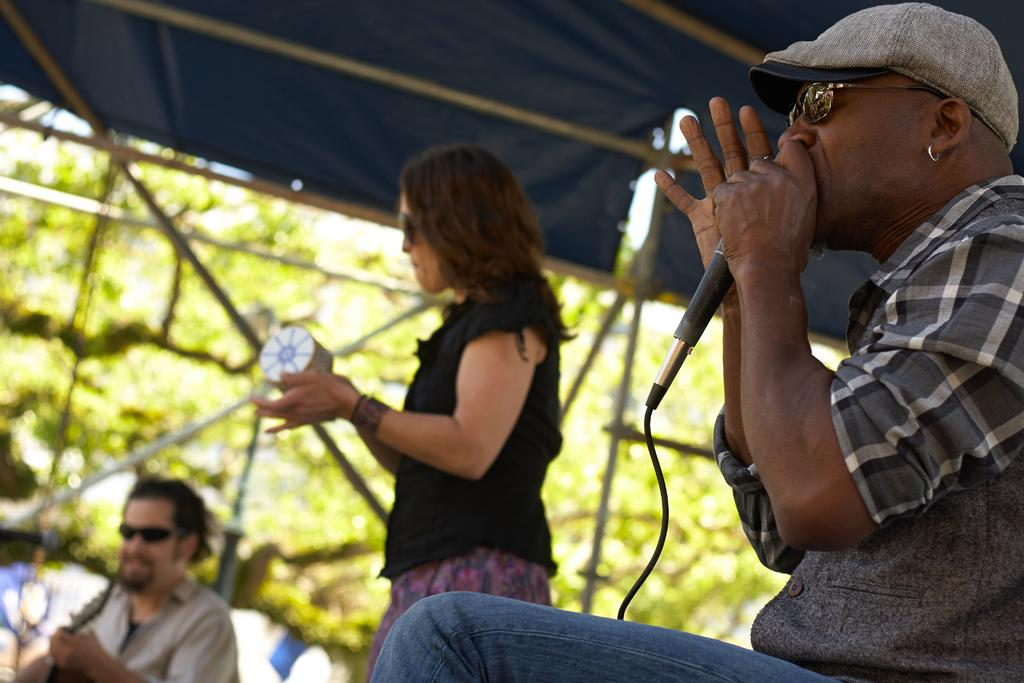How many people are in the image? There are three people in the image. What are the people doing under the tent? One person is holding a guitar, and another person is holding a microphone, which suggests they might be performing. What can be seen outside of the tent? There are trees outside of the tent. What type of soap is being used to wash the trees in the image? There is no soap or tree-washing activity depicted in the image. 